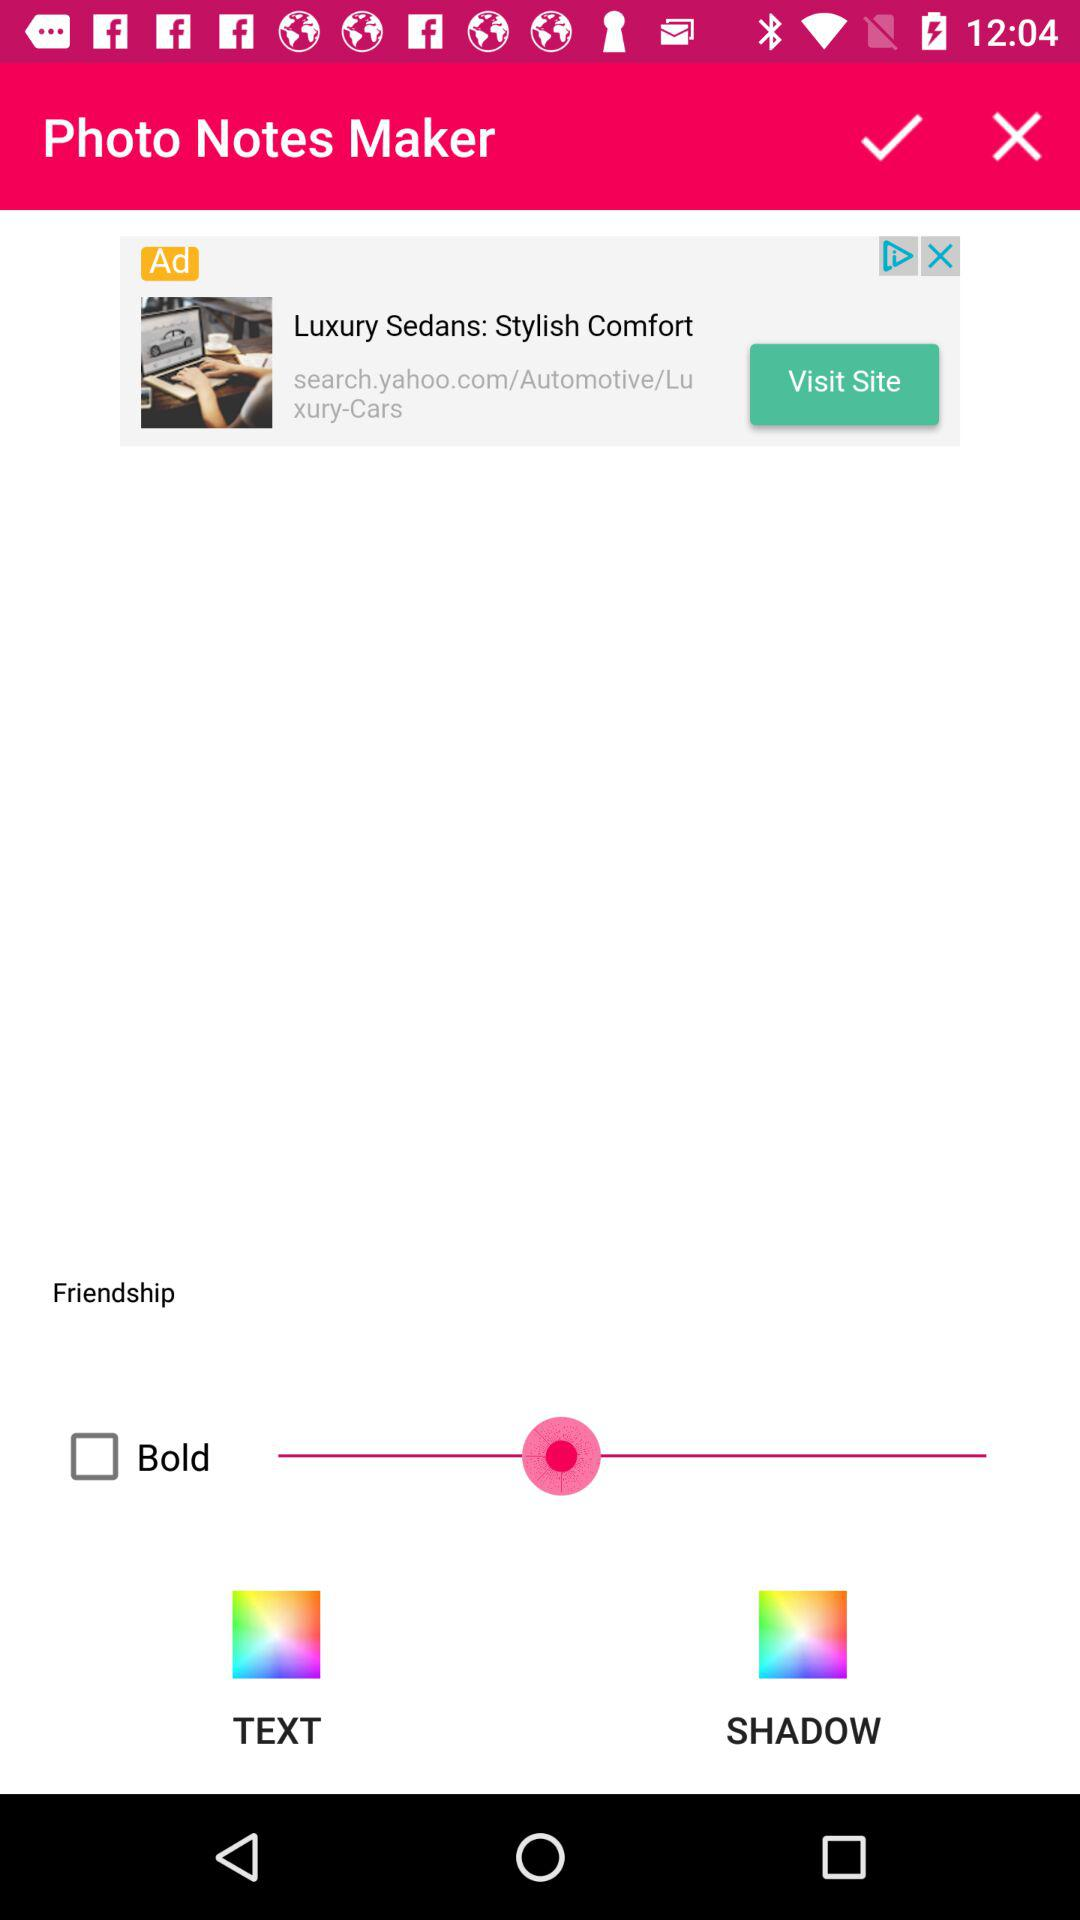What is the status of "Bold"? The status of "Bold" is "off". 